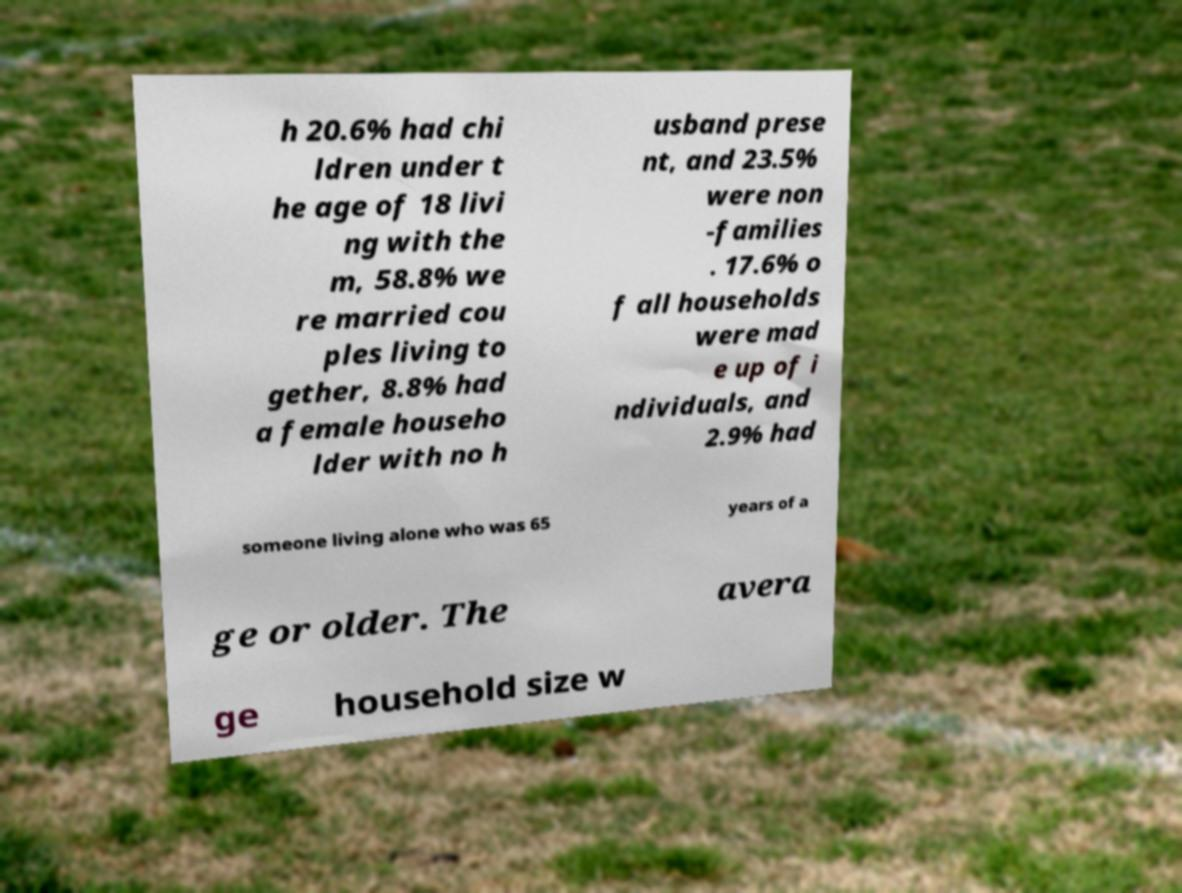What messages or text are displayed in this image? I need them in a readable, typed format. h 20.6% had chi ldren under t he age of 18 livi ng with the m, 58.8% we re married cou ples living to gether, 8.8% had a female househo lder with no h usband prese nt, and 23.5% were non -families . 17.6% o f all households were mad e up of i ndividuals, and 2.9% had someone living alone who was 65 years of a ge or older. The avera ge household size w 